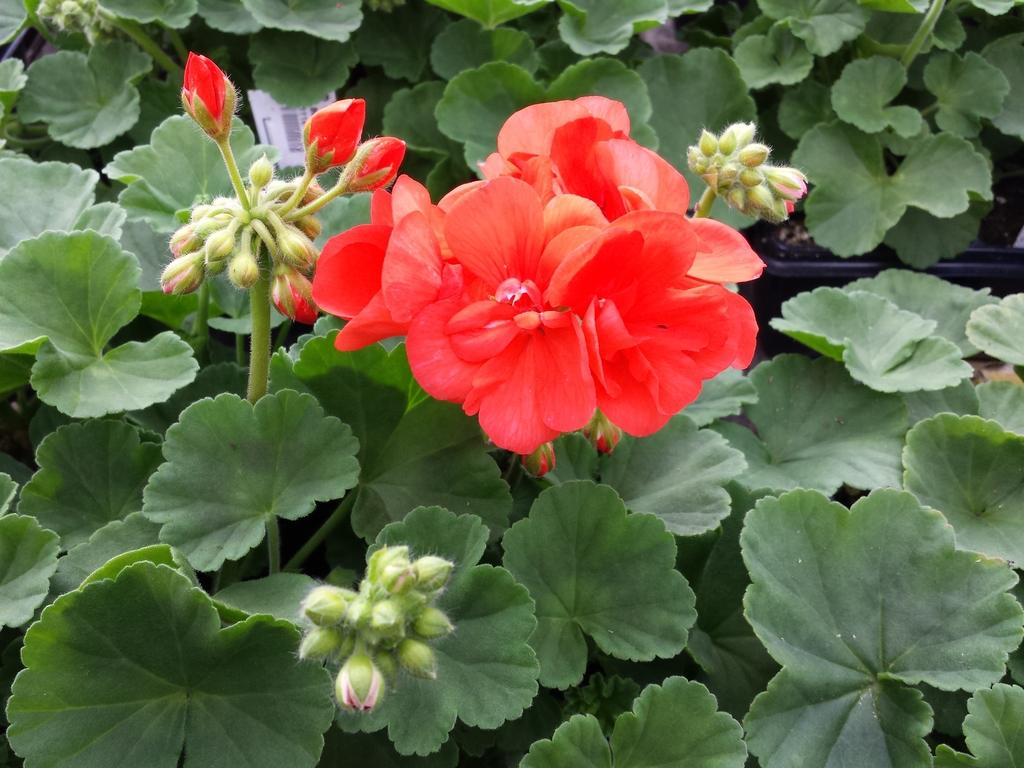What is located in the center of the image? There are plants in the center of the image. What type of plants are present in the image? There are flowers in the image. Can you describe the color of some of the flowers? Some of the flowers are red in color. Who is the manager of the quilt in the image? There is no quilt or manager present in the image. 